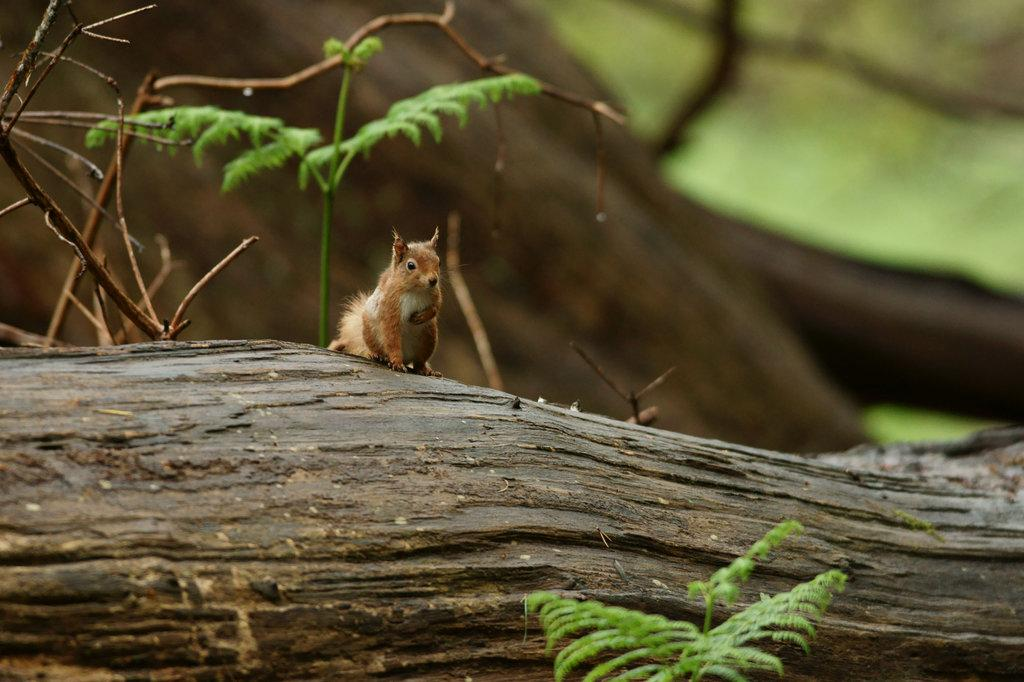What animal can be seen in the image? There is a squirrel in the image. Where is the squirrel located? The squirrel is on the tree bark. What part of the tree is visible in the image? There is a tree trunk visible in the background of the image. What type of toothbrush is the squirrel using in the image? There is no toothbrush present in the image; the squirrel is on the tree bark. 